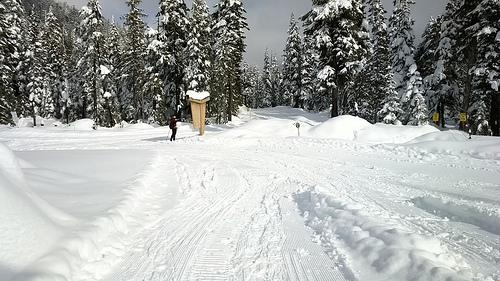Question: what color are the signs on the right?
Choices:
A. Pink.
B. Red.
C. White.
D. Yellow.
Answer with the letter. Answer: D Question: what is on the ground?
Choices:
A. Grass.
B. Dirt.
C. Snow.
D. Sand.
Answer with the letter. Answer: C Question: why is the person outside?
Choices:
A. Picnic.
B. They are skiing.
C. Sunbathing.
D. Having a good time.
Answer with the letter. Answer: B Question: what season is represented in the picture?
Choices:
A. Summer.
B. Fall.
C. Winter.
D. Spring.
Answer with the letter. Answer: C 